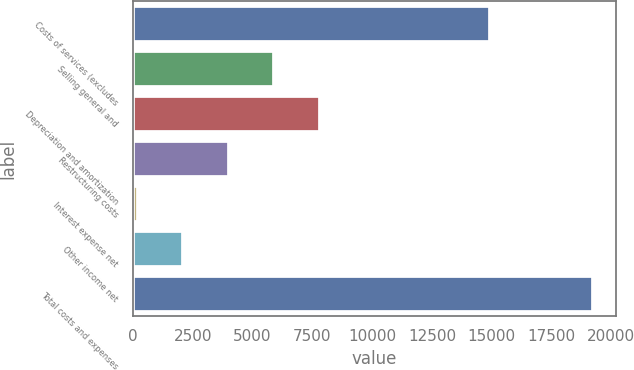Convert chart. <chart><loc_0><loc_0><loc_500><loc_500><bar_chart><fcel>Costs of services (excludes<fcel>Selling general and<fcel>Depreciation and amortization<fcel>Restructuring costs<fcel>Interest expense net<fcel>Other income net<fcel>Total costs and expenses<nl><fcel>14946<fcel>5915.6<fcel>7818.8<fcel>4012.4<fcel>206<fcel>2109.2<fcel>19238<nl></chart> 